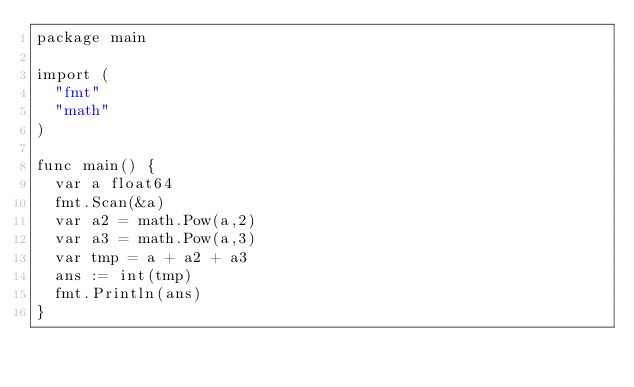<code> <loc_0><loc_0><loc_500><loc_500><_Go_>package main

import (
  "fmt"
  "math"
)

func main() {
  var a float64
  fmt.Scan(&a)
  var a2 = math.Pow(a,2)
  var a3 = math.Pow(a,3)
  var tmp = a + a2 + a3
  ans := int(tmp)
  fmt.Println(ans)
}</code> 